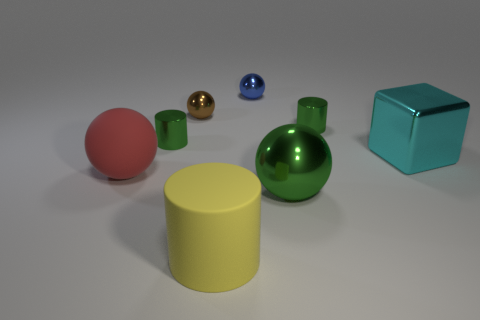Add 1 blue rubber blocks. How many objects exist? 9 Subtract all cylinders. How many objects are left? 5 Subtract all blue metallic spheres. Subtract all green cylinders. How many objects are left? 5 Add 4 tiny green metallic cylinders. How many tiny green metallic cylinders are left? 6 Add 8 big yellow things. How many big yellow things exist? 9 Subtract 0 blue blocks. How many objects are left? 8 